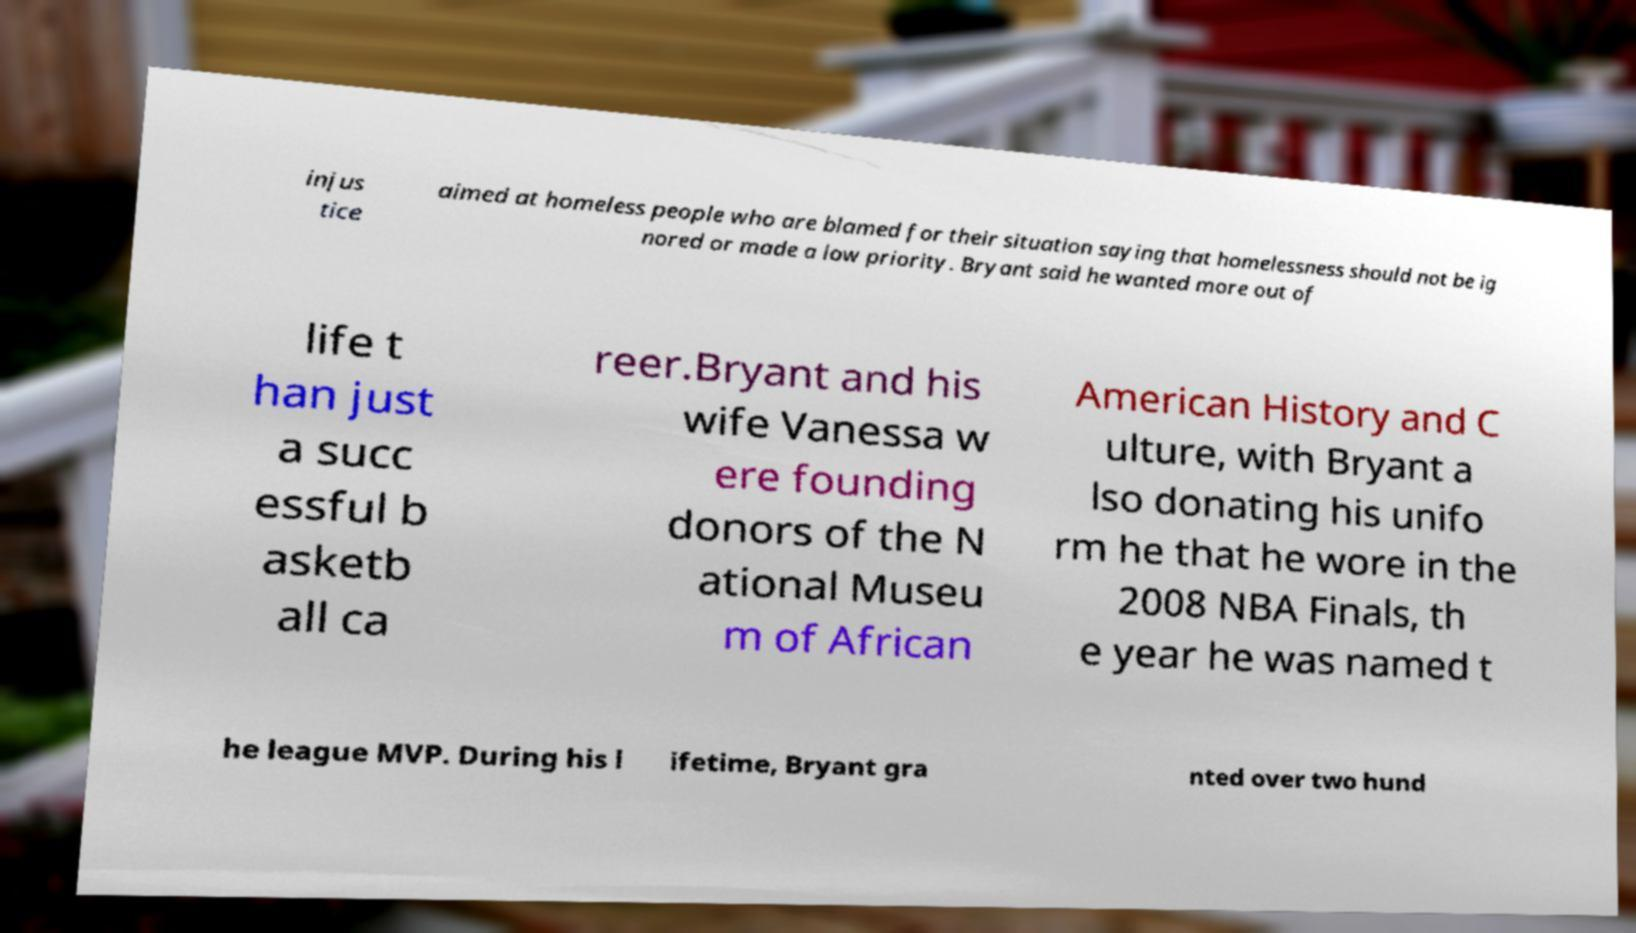There's text embedded in this image that I need extracted. Can you transcribe it verbatim? injus tice aimed at homeless people who are blamed for their situation saying that homelessness should not be ig nored or made a low priority. Bryant said he wanted more out of life t han just a succ essful b asketb all ca reer.Bryant and his wife Vanessa w ere founding donors of the N ational Museu m of African American History and C ulture, with Bryant a lso donating his unifo rm he that he wore in the 2008 NBA Finals, th e year he was named t he league MVP. During his l ifetime, Bryant gra nted over two hund 